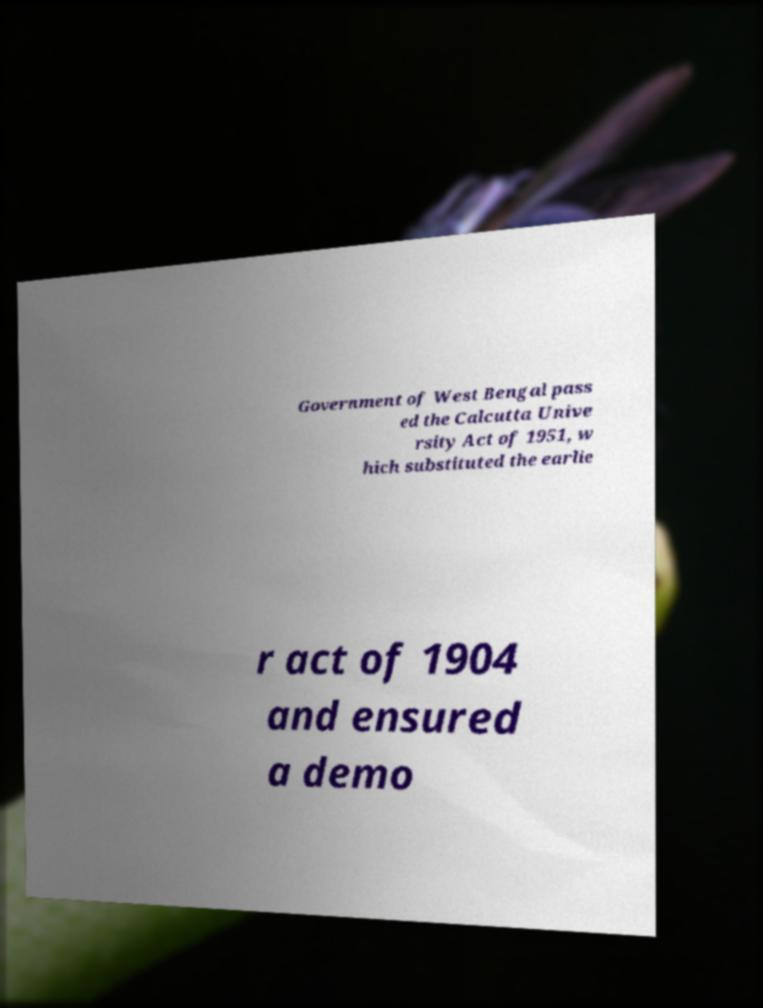For documentation purposes, I need the text within this image transcribed. Could you provide that? Government of West Bengal pass ed the Calcutta Unive rsity Act of 1951, w hich substituted the earlie r act of 1904 and ensured a demo 